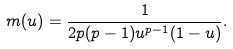<formula> <loc_0><loc_0><loc_500><loc_500>m ( u ) = \frac { 1 } { 2 p ( p - 1 ) u ^ { p - 1 } ( 1 - u ) } .</formula> 